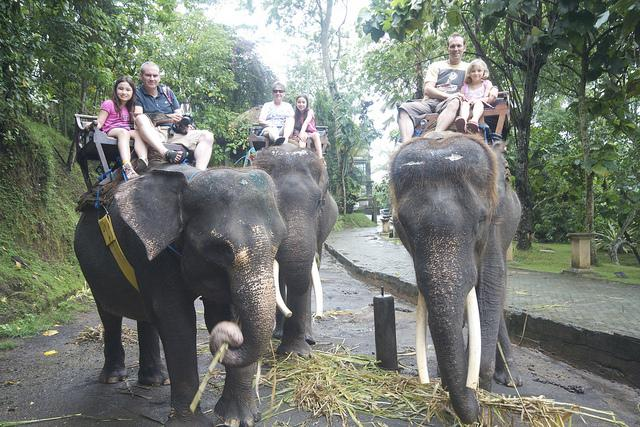How many elephants are standing in the road with people on their backs?

Choices:
A) four
B) three
C) five
D) six three 